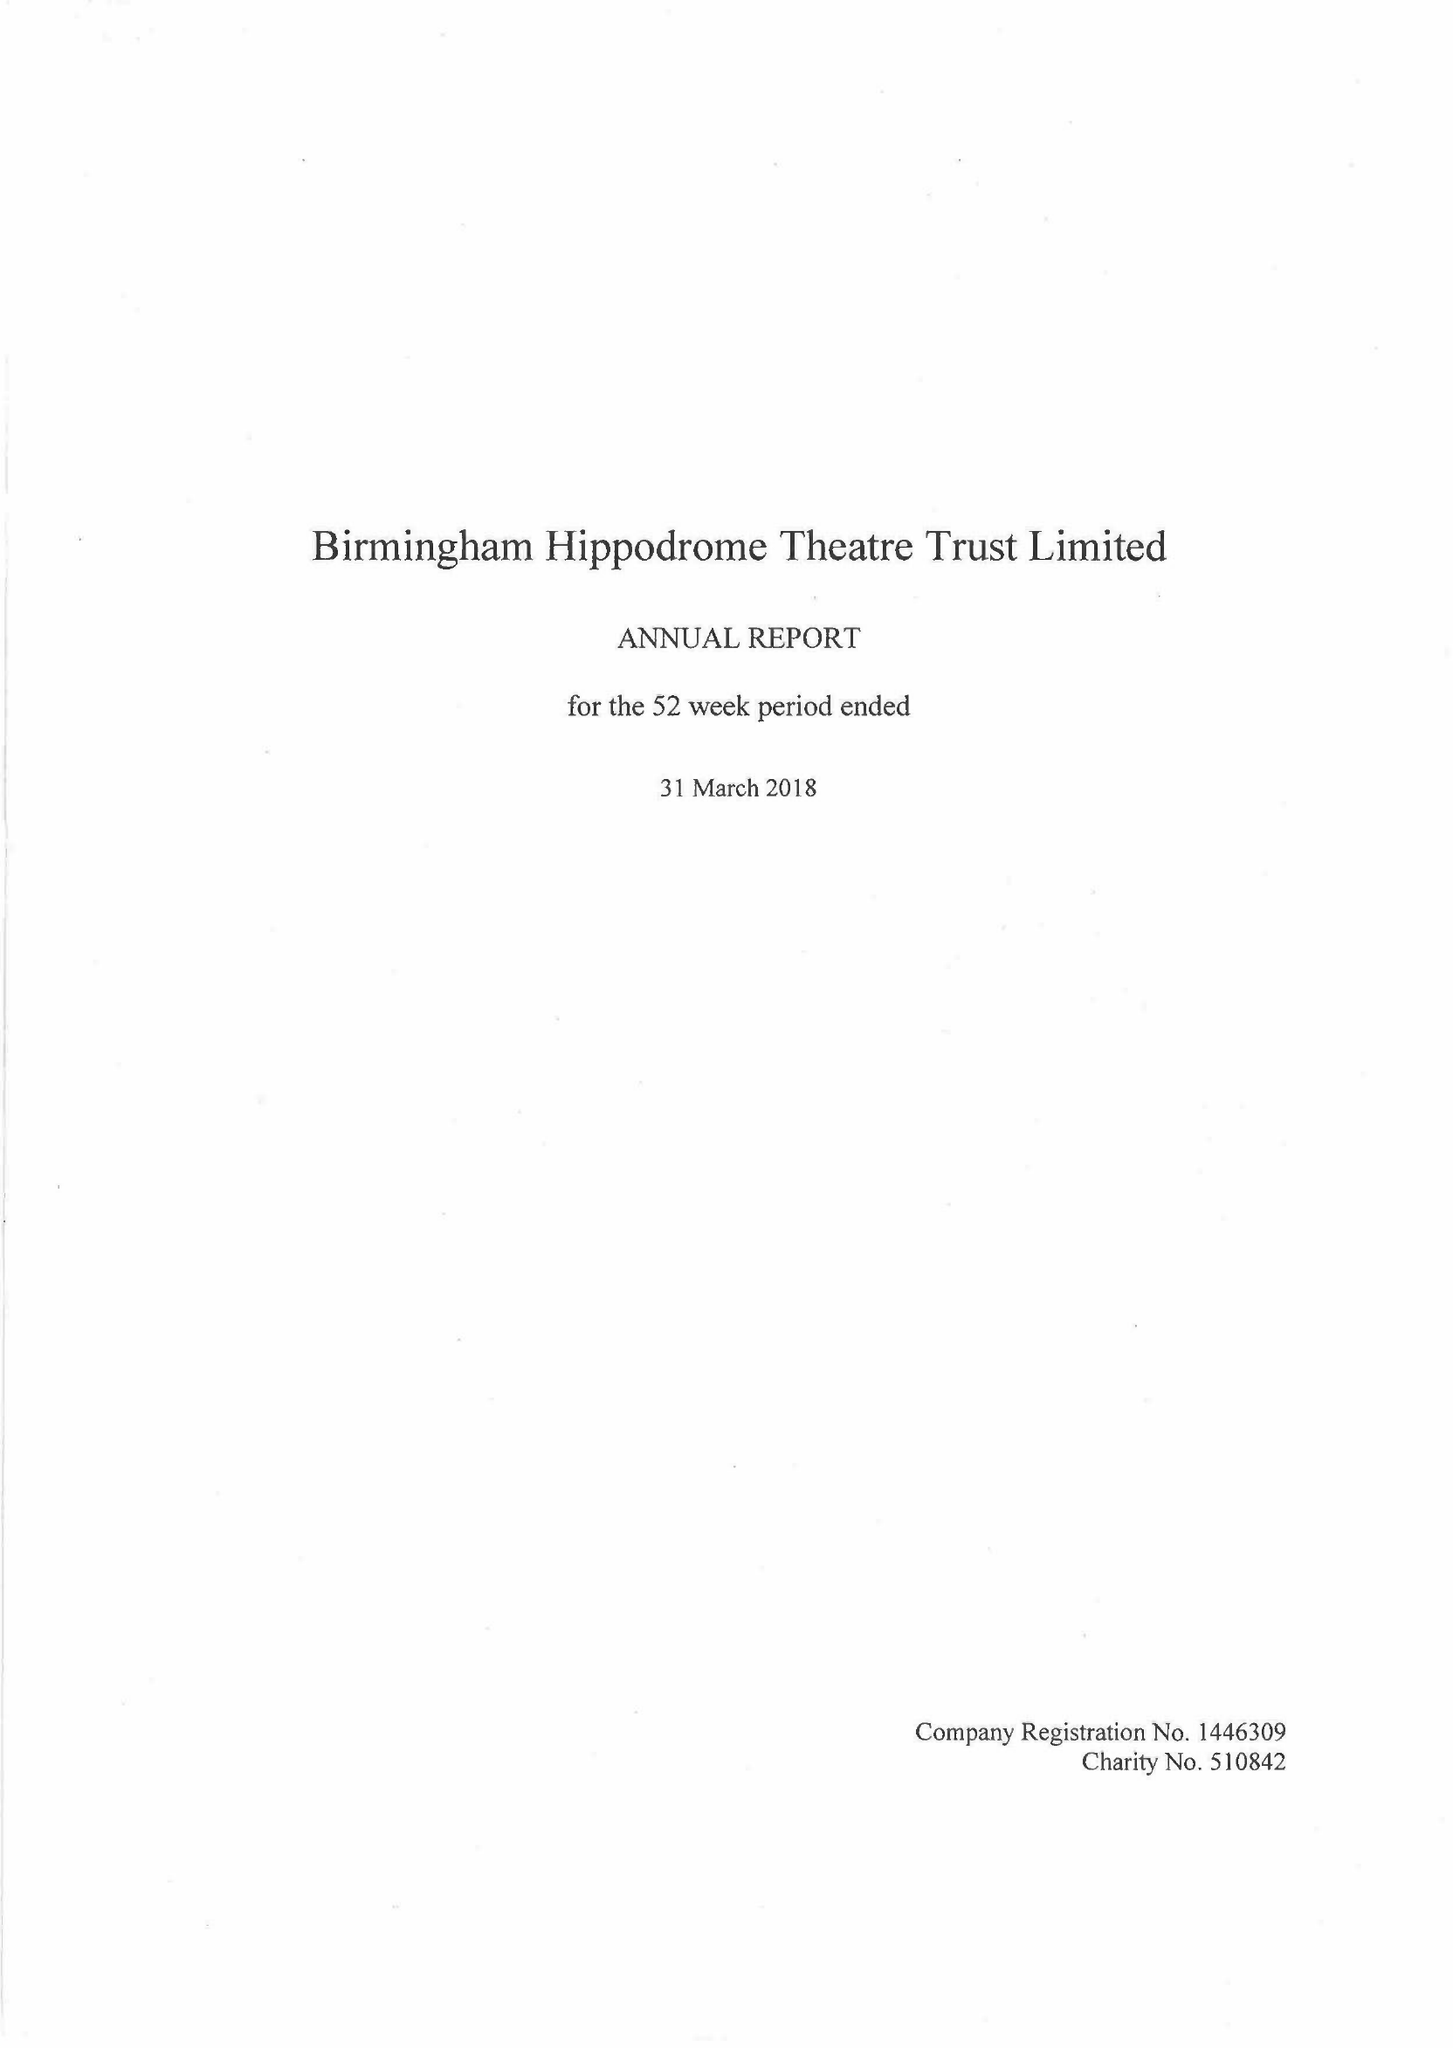What is the value for the income_annually_in_british_pounds?
Answer the question using a single word or phrase. 26272000.00 